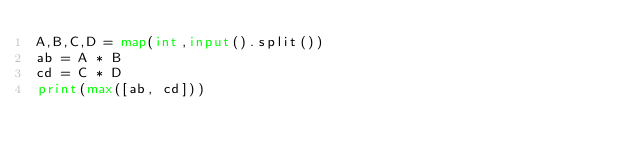Convert code to text. <code><loc_0><loc_0><loc_500><loc_500><_Python_>A,B,C,D = map(int,input().split())
ab = A * B
cd = C * D
print(max([ab, cd]))
</code> 